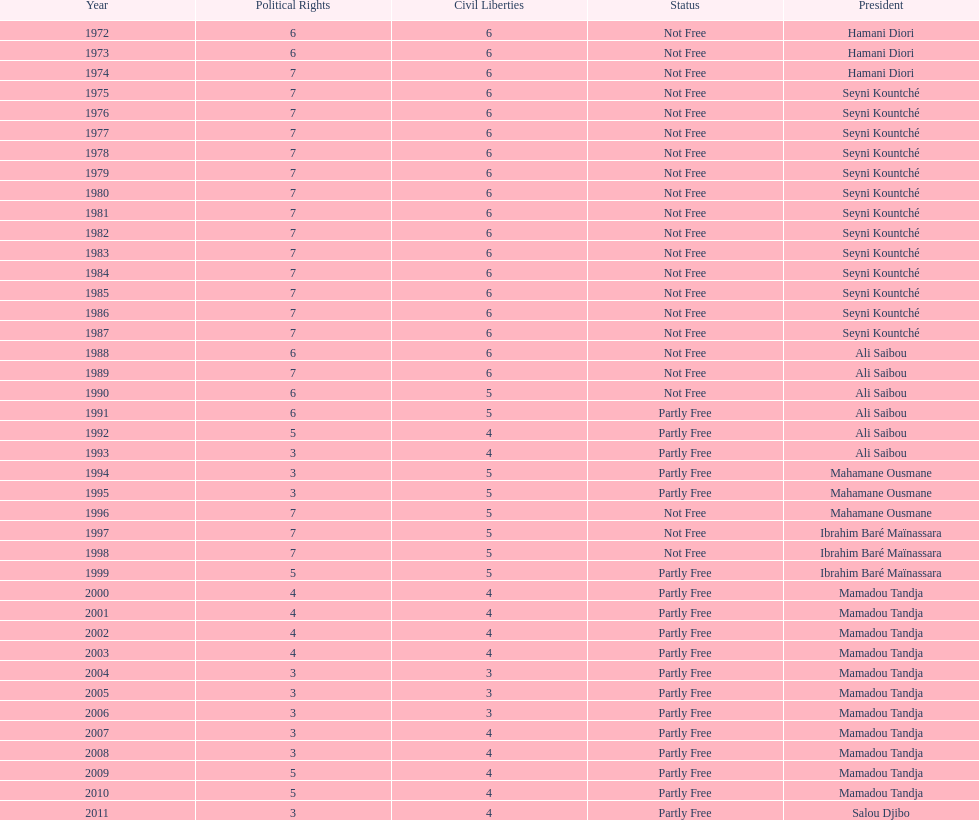Who is the subsequent president mentioned following hamani diori in 1974? Seyni Kountché. 